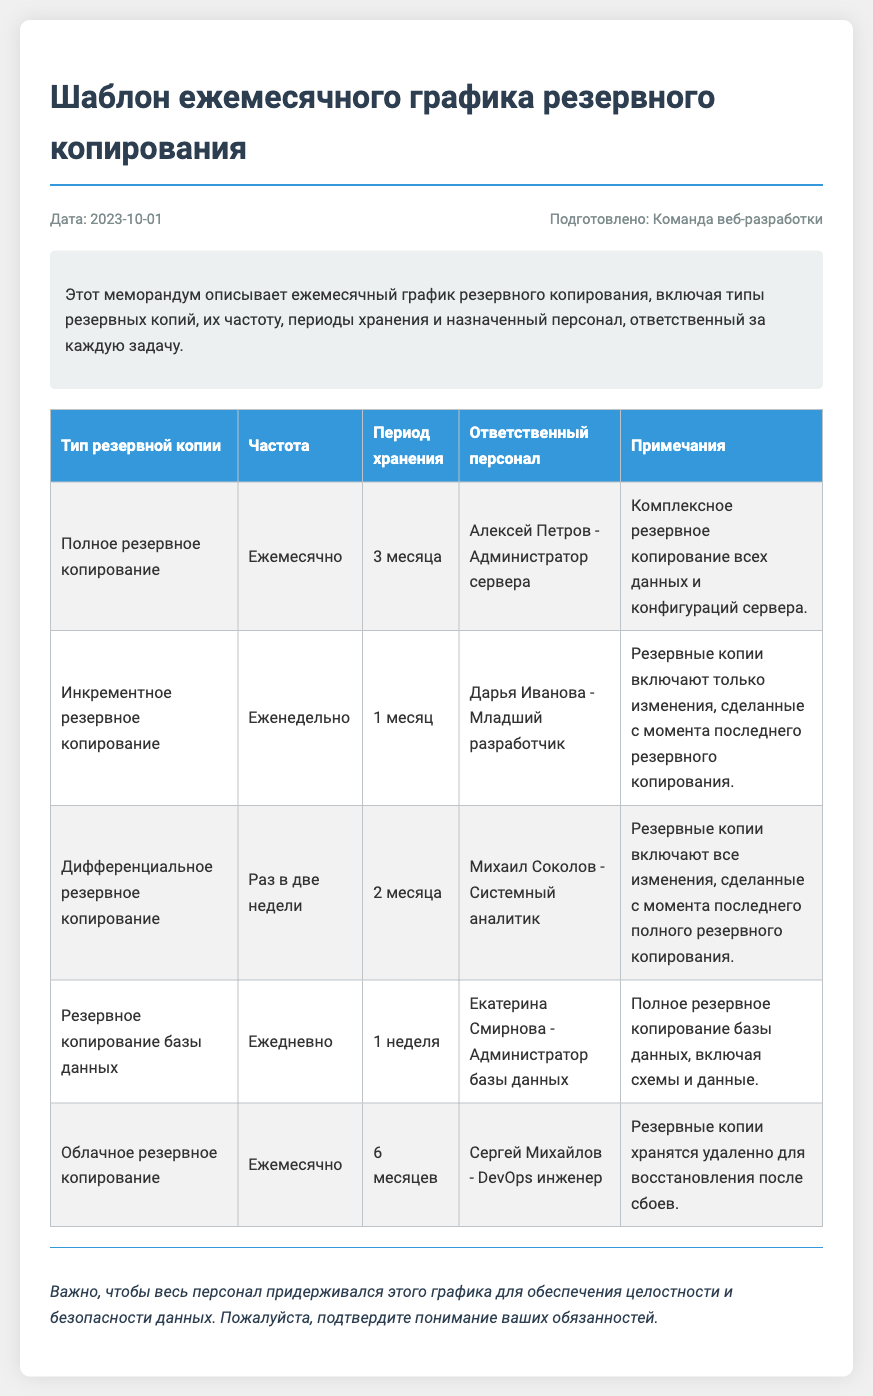Какой тип резервного копирования выполняется ежемесячно? В таблице указано, что полное резервное копирование выполняется ежемесячно.
Answer: Полное резервное копирование Кто отвечает за инкрементное резервное копирование? В документе указано, что инкрементное резервное копирование выполняется Дарьей Ивановой.
Answer: Дарья Иванова Какой период хранения для резервного копирования базы данных? В таблице указано, что период хранения резервного копирования базы данных составляет 1 неделю.
Answer: 1 неделя Что включается в дифференциальное резервное копирование? В описании дифференциального резервного копирования указано, что оно включает все изменения с момента последнего полного резервного копирования.
Answer: Все изменения с момента последнего полного резервного копирования Какова частота облачного резервного копирования? В документе указано, что облачное резервное копирование выполняется ежемесячно.
Answer: Ежемесячно 